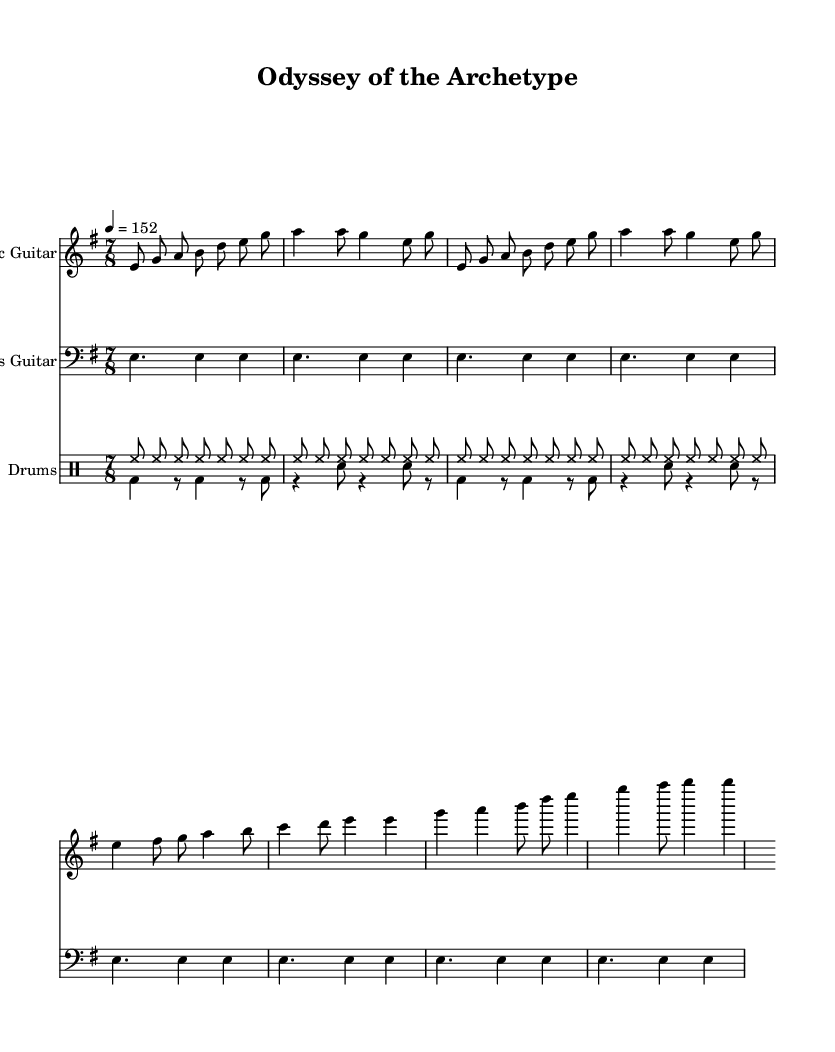What is the key signature of this music? The key signature is E minor, which has one sharp (F#).
Answer: E minor What is the time signature of this piece? The time signature is 7/8, indicating there are seven eighth notes per measure.
Answer: 7/8 What is the tempo marking of the music? The tempo marking indicates a quarter note equals 152 beats per minute.
Answer: 152 How many times is the main riff repeated in the electric guitar part? The main riff in the electric guitar part is repeated twice, as indicated by the repeat symbol.
Answer: 2 What is the note that the bass guitar consistently plays in the main riff? The bass guitar consistently plays the note E in whole note duration throughout the main riff.
Answer: E What instrument is playing the main melody during the verse? The main melody during the verse is played by the electric guitar.
Answer: Electric Guitar What type of drum pattern is primarily used in the song? The drum pattern primarily uses a hi-hat pattern, common in metal music, with a consistent rhythm throughout.
Answer: Hi-hat 